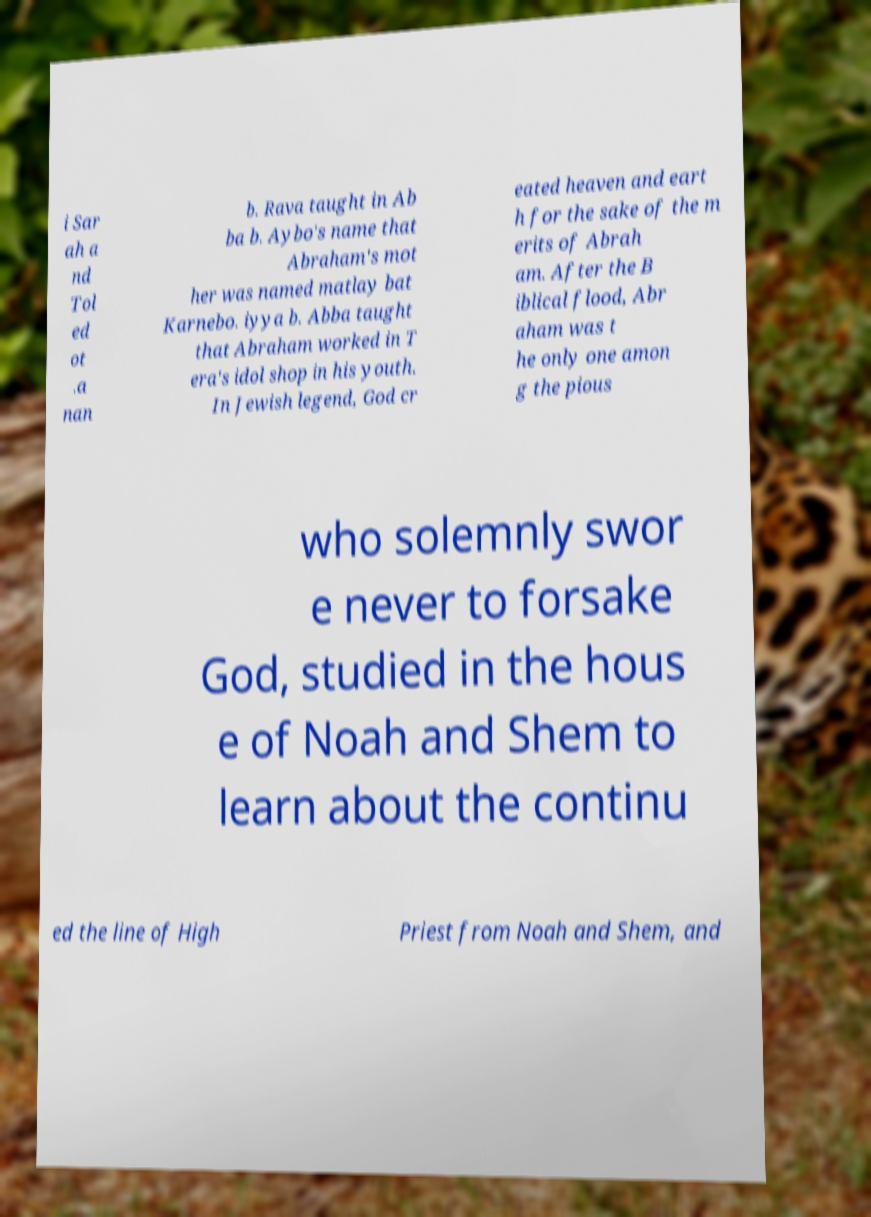Please read and relay the text visible in this image. What does it say? i Sar ah a nd Tol ed ot .a nan b. Rava taught in Ab ba b. Aybo's name that Abraham's mot her was named matlay bat Karnebo. iyya b. Abba taught that Abraham worked in T era's idol shop in his youth. In Jewish legend, God cr eated heaven and eart h for the sake of the m erits of Abrah am. After the B iblical flood, Abr aham was t he only one amon g the pious who solemnly swor e never to forsake God, studied in the hous e of Noah and Shem to learn about the continu ed the line of High Priest from Noah and Shem, and 